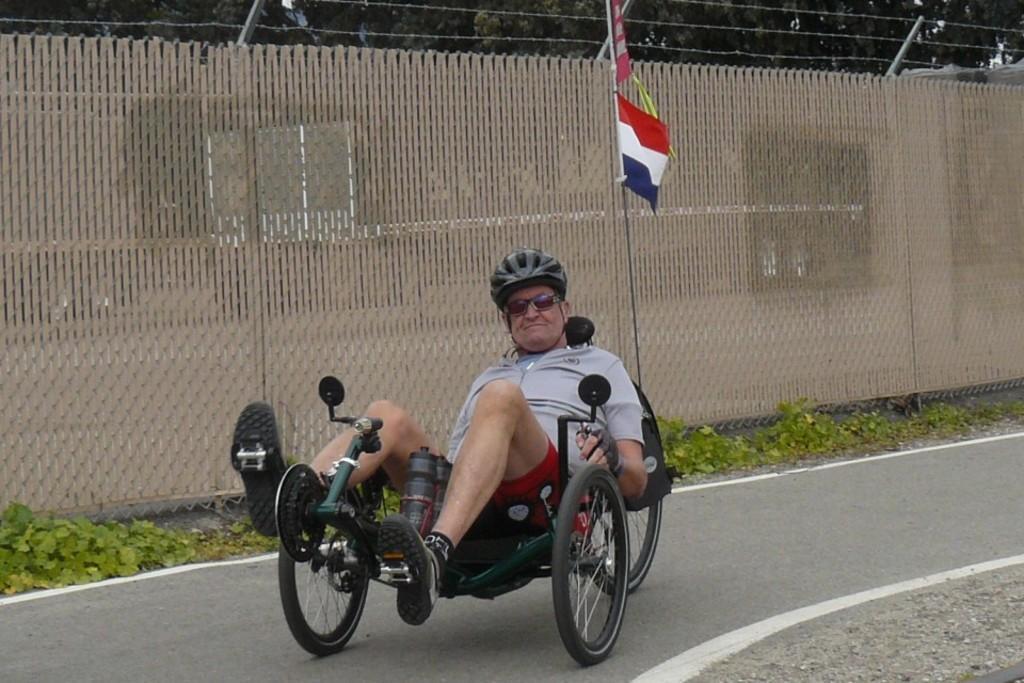Describe this image in one or two sentences. In this image we can see a man sitting on a wheelchair. There are many trees and plants in the image. There is a road, a flag and a fencing in the image. 